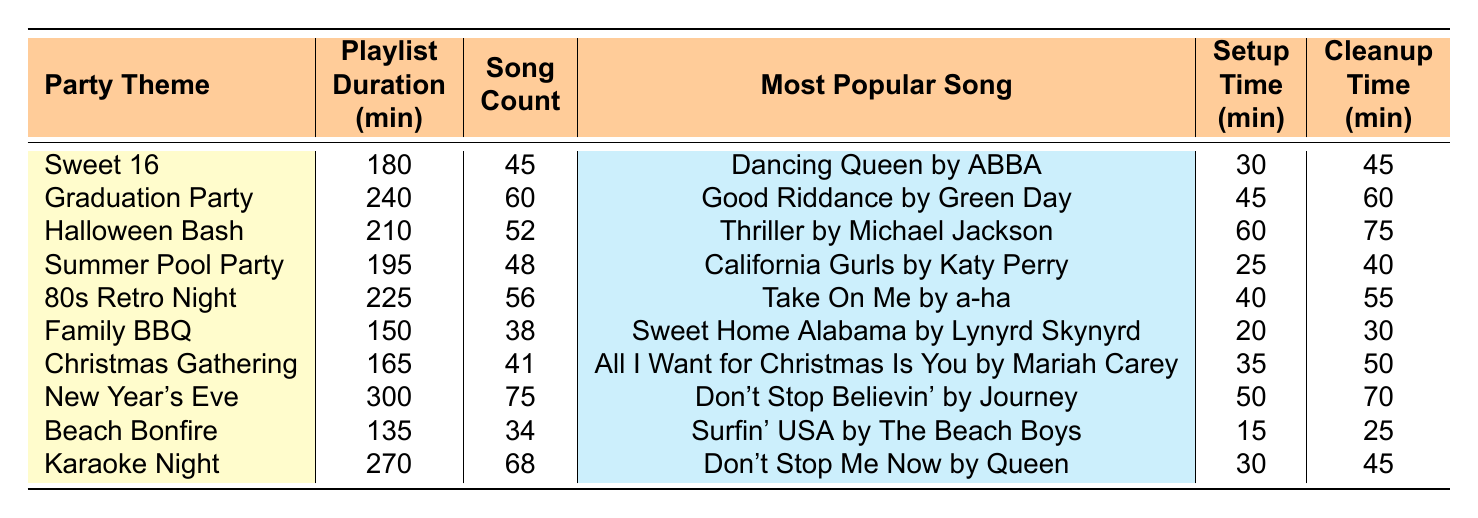What is the playlist duration for the "Summer Pool Party"? The table lists the playlist duration for each party theme, and for "Summer Pool Party," it shows 195 minutes.
Answer: 195 minutes Which party theme has the highest song count? By checking the song counts for all themes, "New Year's Eve" has 75 songs, which is higher than the others listed.
Answer: New Year's Eve What is the setup time for the "Karaoke Night"? The "Karaoke Night" row in the table shows a setup time of 30 minutes.
Answer: 30 minutes What is the average playlist duration across all themes? The total playlist duration is calculated as (180 + 240 + 210 + 195 + 225 + 150 + 165 + 300 + 135 + 270) = 1875 minutes. There are 10 themes, so the average is 1875 / 10 = 187.5 minutes.
Answer: 187.5 minutes How many more songs does the "Graduation Party" have compared to the "Family BBQ"? The "Graduation Party" has 60 songs, while "Family BBQ" has 38 songs. The difference is 60 - 38 = 22 songs.
Answer: 22 songs Is the most popular song for "Christmas Gathering" "All I Want for Christmas Is You"? Looking at the "Christmas Gathering" row, it confirms that the most popular song listed is indeed "All I Want for Christmas Is You."
Answer: Yes What is the total cleanup time for both the "Halloween Bash" and "New Year's Eve"? The cleanup time for "Halloween Bash" is 75 minutes, and for "New Year's Eve," it is 70 minutes. Adding these gives 75 + 70 = 145 minutes.
Answer: 145 minutes Which party theme has the shortest playlist duration? Examining the playlist durations, "Beach Bonfire" has the shortest duration at 135 minutes.
Answer: Beach Bonfire If we combine the setup times of "Sweet 16" and "80s Retro Night," what is the total? The setup time for "Sweet 16" is 30 minutes and for "80s Retro Night," it is 40 minutes. Adding these gives 30 + 40 = 70 minutes for setup.
Answer: 70 minutes Are there any party themes with a playlist duration of more than 250 minutes? The only theme with a playlist duration above 250 minutes is "New Year's Eve," which has a duration of 300 minutes.
Answer: Yes 